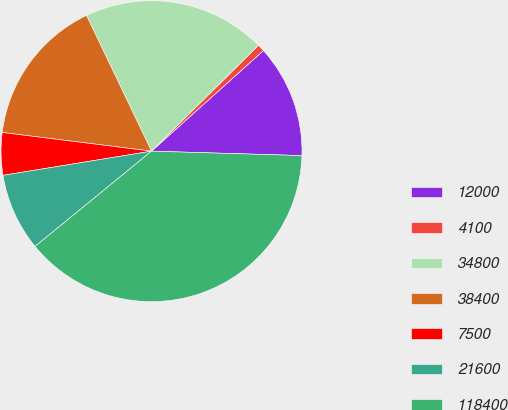Convert chart. <chart><loc_0><loc_0><loc_500><loc_500><pie_chart><fcel>12000<fcel>4100<fcel>34800<fcel>38400<fcel>7500<fcel>21600<fcel>118400<nl><fcel>12.12%<fcel>0.77%<fcel>19.69%<fcel>15.91%<fcel>4.55%<fcel>8.34%<fcel>38.62%<nl></chart> 